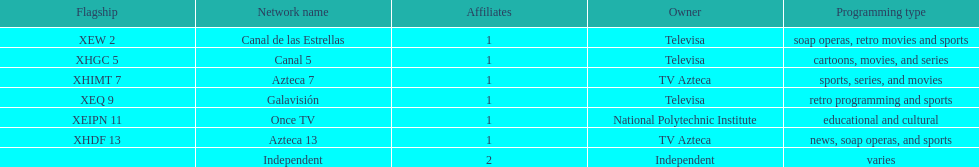What is the average number of affiliates that a given network will have? 1. 